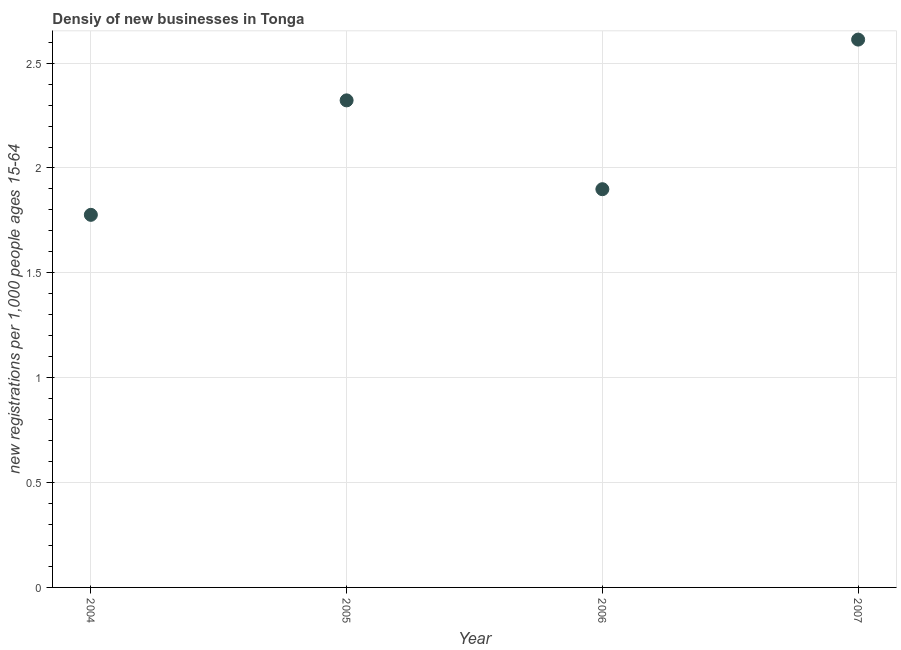What is the density of new business in 2005?
Provide a succinct answer. 2.32. Across all years, what is the maximum density of new business?
Keep it short and to the point. 2.61. Across all years, what is the minimum density of new business?
Your response must be concise. 1.78. In which year was the density of new business maximum?
Give a very brief answer. 2007. In which year was the density of new business minimum?
Your answer should be compact. 2004. What is the sum of the density of new business?
Keep it short and to the point. 8.61. What is the difference between the density of new business in 2005 and 2007?
Your answer should be compact. -0.29. What is the average density of new business per year?
Provide a succinct answer. 2.15. What is the median density of new business?
Provide a succinct answer. 2.11. Do a majority of the years between 2006 and 2004 (inclusive) have density of new business greater than 0.30000000000000004 ?
Offer a very short reply. No. What is the ratio of the density of new business in 2005 to that in 2006?
Offer a terse response. 1.22. Is the difference between the density of new business in 2005 and 2007 greater than the difference between any two years?
Give a very brief answer. No. What is the difference between the highest and the second highest density of new business?
Your answer should be compact. 0.29. What is the difference between the highest and the lowest density of new business?
Keep it short and to the point. 0.84. How many years are there in the graph?
Provide a succinct answer. 4. What is the difference between two consecutive major ticks on the Y-axis?
Your answer should be compact. 0.5. Are the values on the major ticks of Y-axis written in scientific E-notation?
Provide a short and direct response. No. What is the title of the graph?
Make the answer very short. Densiy of new businesses in Tonga. What is the label or title of the X-axis?
Your response must be concise. Year. What is the label or title of the Y-axis?
Provide a succinct answer. New registrations per 1,0 people ages 15-64. What is the new registrations per 1,000 people ages 15-64 in 2004?
Ensure brevity in your answer.  1.78. What is the new registrations per 1,000 people ages 15-64 in 2005?
Give a very brief answer. 2.32. What is the new registrations per 1,000 people ages 15-64 in 2006?
Make the answer very short. 1.9. What is the new registrations per 1,000 people ages 15-64 in 2007?
Provide a succinct answer. 2.61. What is the difference between the new registrations per 1,000 people ages 15-64 in 2004 and 2005?
Offer a terse response. -0.55. What is the difference between the new registrations per 1,000 people ages 15-64 in 2004 and 2006?
Your response must be concise. -0.12. What is the difference between the new registrations per 1,000 people ages 15-64 in 2004 and 2007?
Offer a terse response. -0.84. What is the difference between the new registrations per 1,000 people ages 15-64 in 2005 and 2006?
Offer a very short reply. 0.42. What is the difference between the new registrations per 1,000 people ages 15-64 in 2005 and 2007?
Your answer should be compact. -0.29. What is the difference between the new registrations per 1,000 people ages 15-64 in 2006 and 2007?
Provide a short and direct response. -0.71. What is the ratio of the new registrations per 1,000 people ages 15-64 in 2004 to that in 2005?
Your answer should be compact. 0.77. What is the ratio of the new registrations per 1,000 people ages 15-64 in 2004 to that in 2006?
Your answer should be compact. 0.94. What is the ratio of the new registrations per 1,000 people ages 15-64 in 2004 to that in 2007?
Your answer should be very brief. 0.68. What is the ratio of the new registrations per 1,000 people ages 15-64 in 2005 to that in 2006?
Ensure brevity in your answer.  1.22. What is the ratio of the new registrations per 1,000 people ages 15-64 in 2005 to that in 2007?
Your answer should be compact. 0.89. What is the ratio of the new registrations per 1,000 people ages 15-64 in 2006 to that in 2007?
Provide a succinct answer. 0.73. 